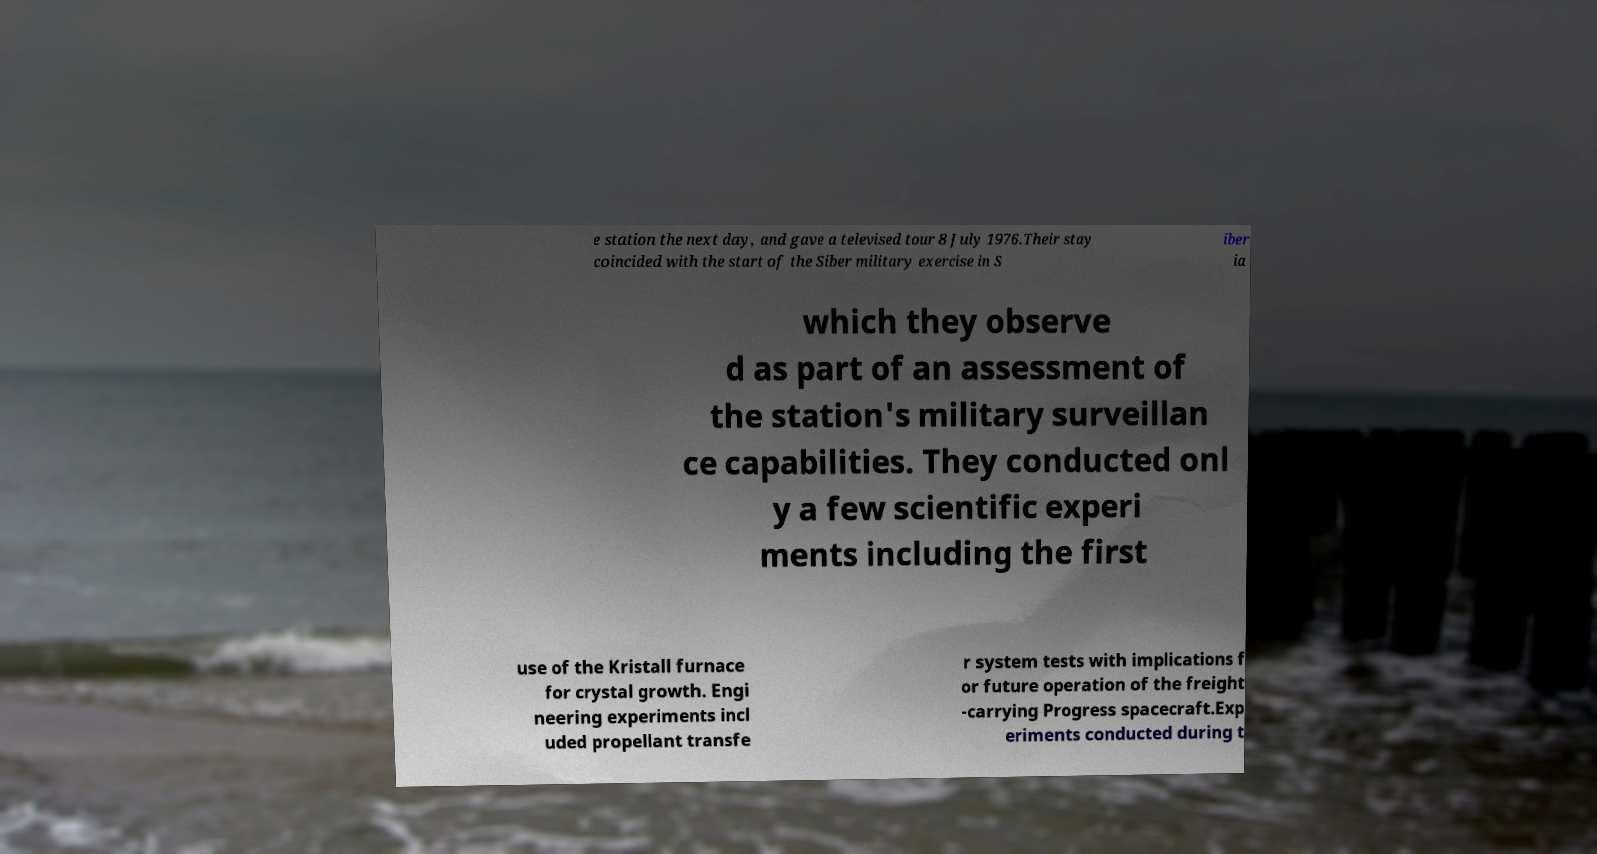Please read and relay the text visible in this image. What does it say? e station the next day, and gave a televised tour 8 July 1976.Their stay coincided with the start of the Siber military exercise in S iber ia which they observe d as part of an assessment of the station's military surveillan ce capabilities. They conducted onl y a few scientific experi ments including the first use of the Kristall furnace for crystal growth. Engi neering experiments incl uded propellant transfe r system tests with implications f or future operation of the freight -carrying Progress spacecraft.Exp eriments conducted during t 